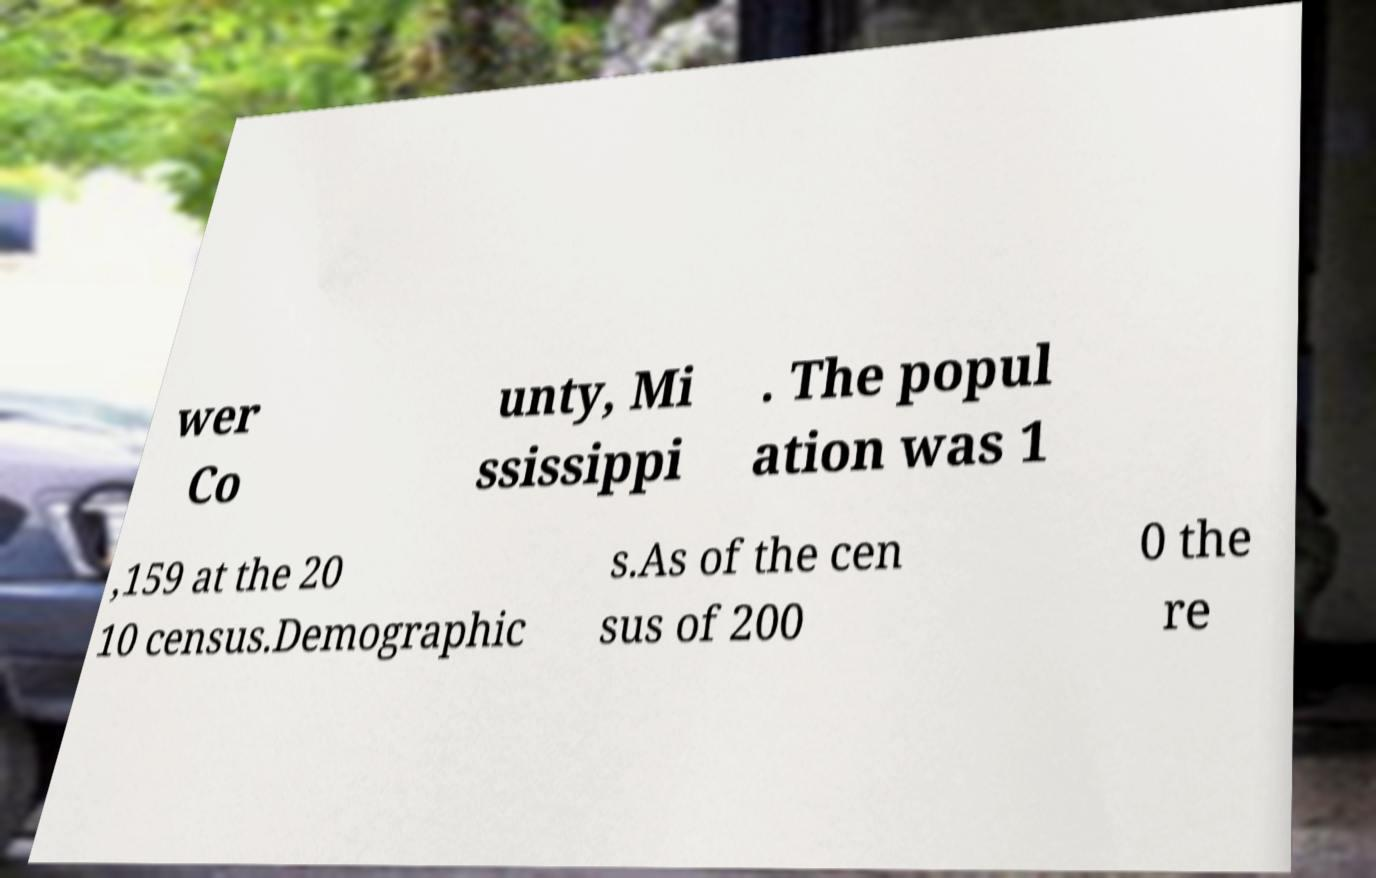Can you accurately transcribe the text from the provided image for me? wer Co unty, Mi ssissippi . The popul ation was 1 ,159 at the 20 10 census.Demographic s.As of the cen sus of 200 0 the re 